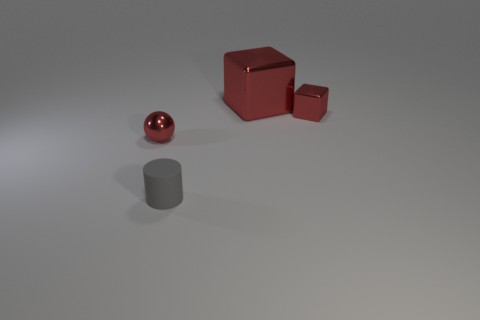Are there any other things that have the same material as the cylinder?
Offer a terse response. No. Do the small shiny object behind the tiny red metallic ball and the thing that is on the left side of the tiny gray cylinder have the same color?
Provide a short and direct response. Yes. How many objects are on the left side of the large cube and behind the gray rubber cylinder?
Offer a terse response. 1. What number of other things are there of the same shape as the tiny gray rubber thing?
Make the answer very short. 0. Is the number of red cubes behind the tiny block greater than the number of red objects?
Offer a terse response. No. What color is the tiny metal thing that is on the left side of the gray matte thing?
Keep it short and to the point. Red. There is another cube that is the same color as the big block; what is its size?
Make the answer very short. Small. What number of matte objects are either small purple cylinders or red cubes?
Your answer should be very brief. 0. Are there any tiny red shiny things on the right side of the red cube behind the tiny red shiny thing on the right side of the sphere?
Offer a very short reply. Yes. There is a big object; how many large red shiny objects are on the left side of it?
Your answer should be compact. 0. 